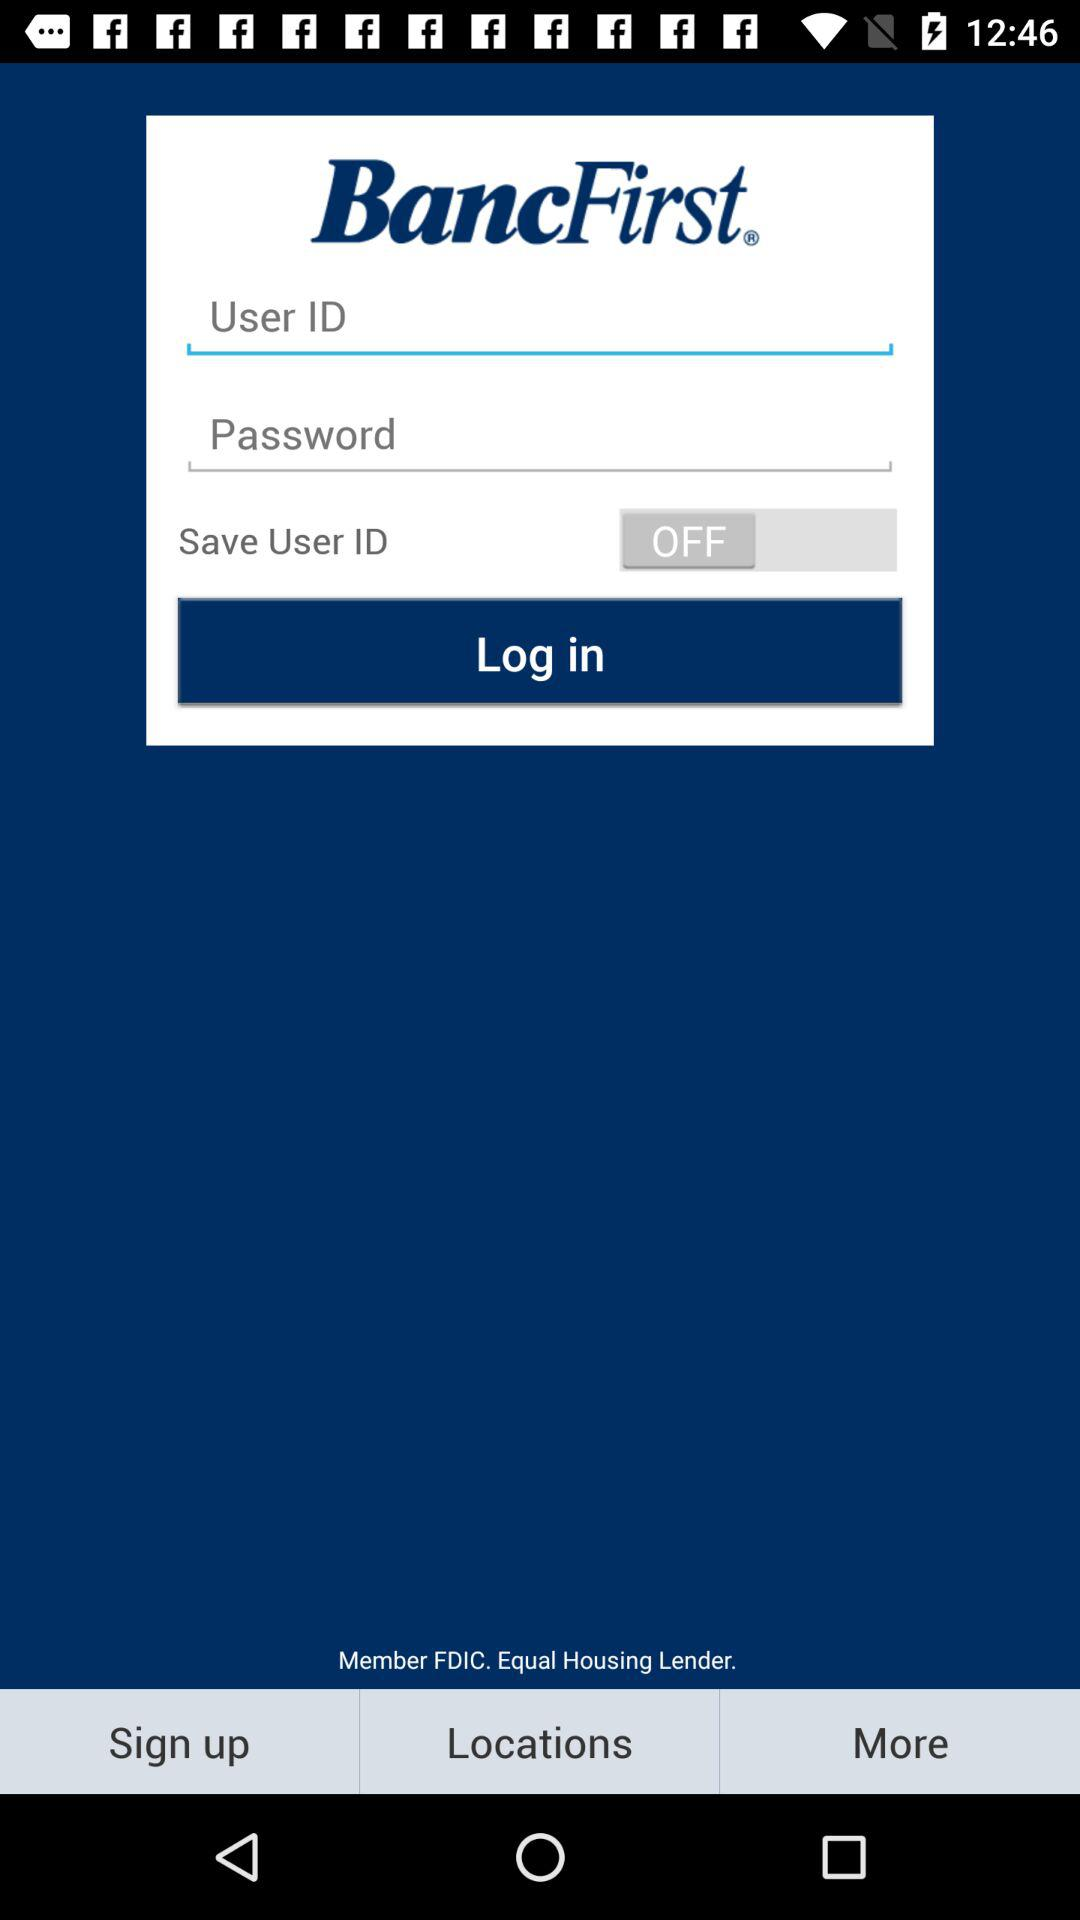What is the status of "Save User ID"? The status is "off". 